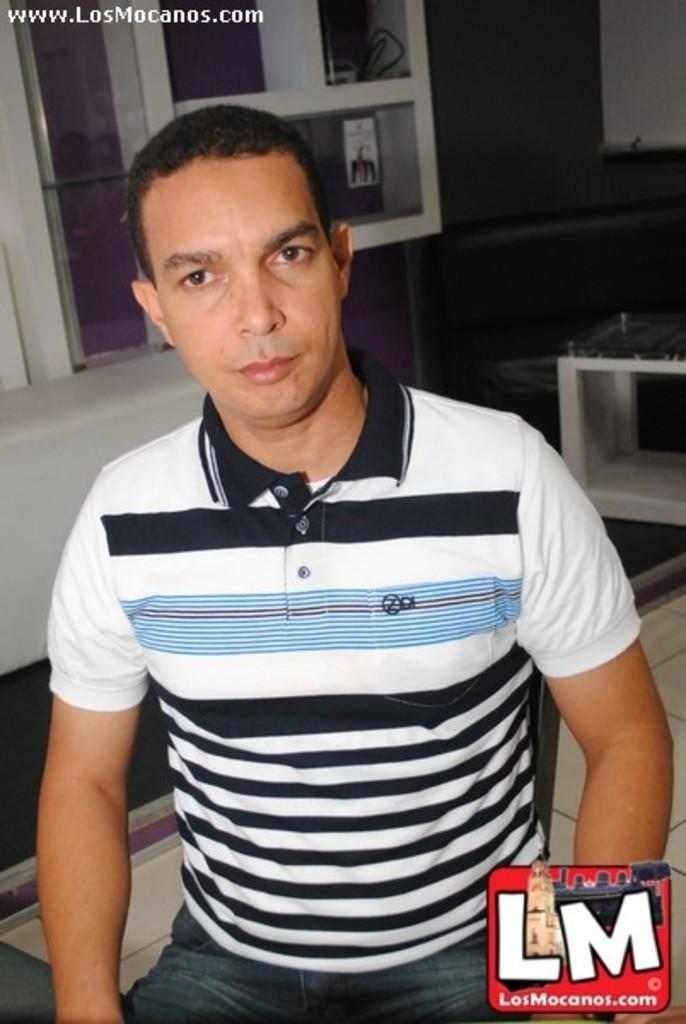<image>
Summarize the visual content of the image. sitting guy with striped shirt and website of www.losmocanos.com at top of picture and LM at bottom right 